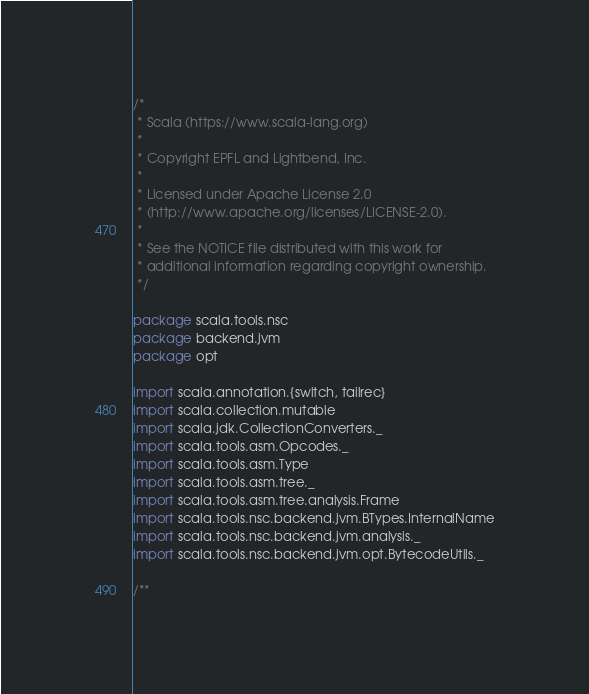Convert code to text. <code><loc_0><loc_0><loc_500><loc_500><_Scala_>/*
 * Scala (https://www.scala-lang.org)
 *
 * Copyright EPFL and Lightbend, Inc.
 *
 * Licensed under Apache License 2.0
 * (http://www.apache.org/licenses/LICENSE-2.0).
 *
 * See the NOTICE file distributed with this work for
 * additional information regarding copyright ownership.
 */

package scala.tools.nsc
package backend.jvm
package opt

import scala.annotation.{switch, tailrec}
import scala.collection.mutable
import scala.jdk.CollectionConverters._
import scala.tools.asm.Opcodes._
import scala.tools.asm.Type
import scala.tools.asm.tree._
import scala.tools.asm.tree.analysis.Frame
import scala.tools.nsc.backend.jvm.BTypes.InternalName
import scala.tools.nsc.backend.jvm.analysis._
import scala.tools.nsc.backend.jvm.opt.BytecodeUtils._

/**</code> 